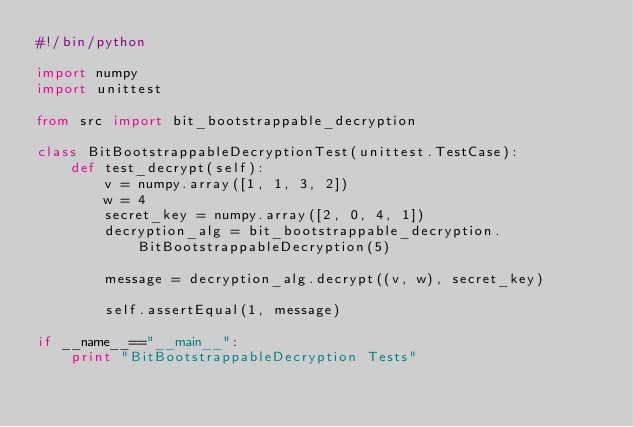<code> <loc_0><loc_0><loc_500><loc_500><_Python_>#!/bin/python

import numpy
import unittest

from src import bit_bootstrappable_decryption

class BitBootstrappableDecryptionTest(unittest.TestCase):
    def test_decrypt(self):
        v = numpy.array([1, 1, 3, 2])
        w = 4
        secret_key = numpy.array([2, 0, 4, 1])
        decryption_alg = bit_bootstrappable_decryption.BitBootstrappableDecryption(5)
        
        message = decryption_alg.decrypt((v, w), secret_key)
        
        self.assertEqual(1, message)

if __name__=="__main__":
    print "BitBootstrappableDecryption Tests"</code> 